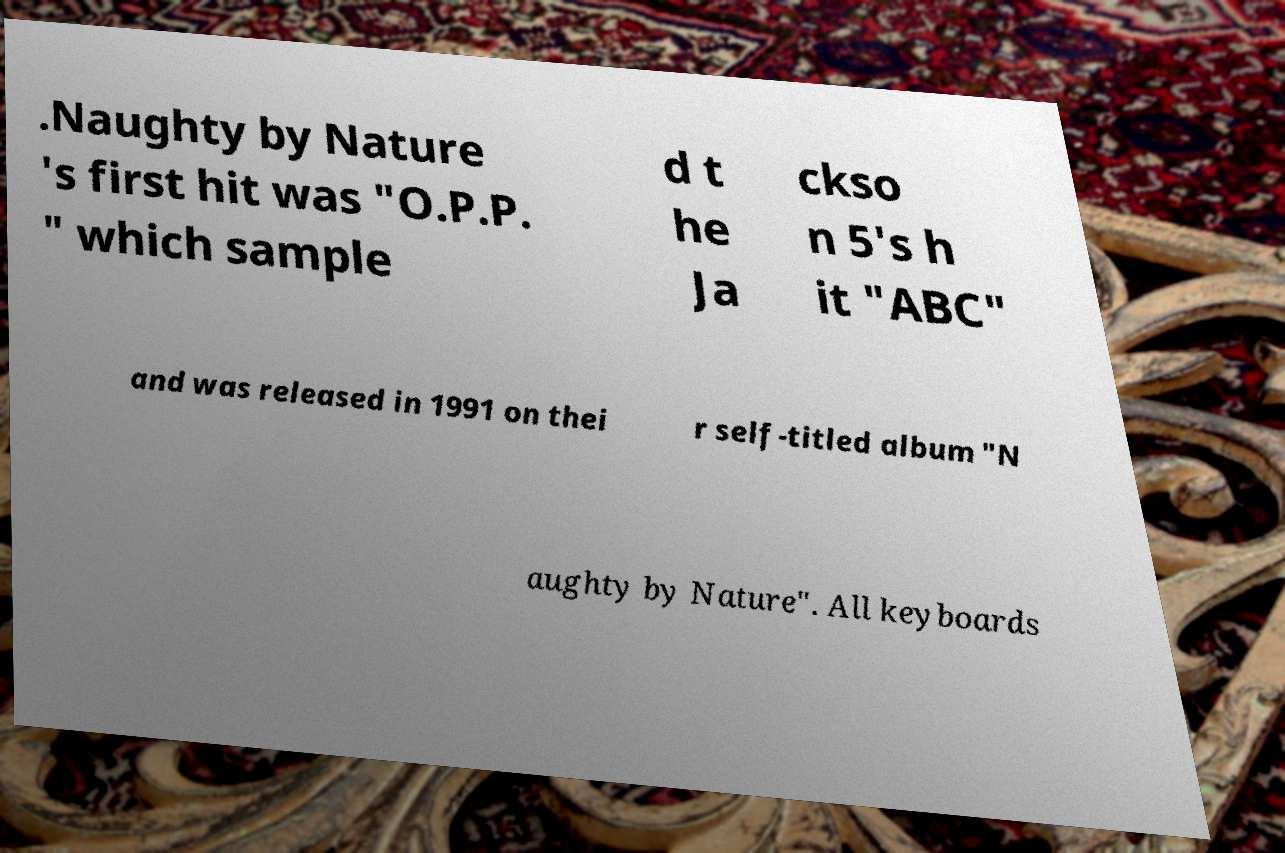Could you assist in decoding the text presented in this image and type it out clearly? .Naughty by Nature 's first hit was "O.P.P. " which sample d t he Ja ckso n 5's h it "ABC" and was released in 1991 on thei r self-titled album "N aughty by Nature". All keyboards 